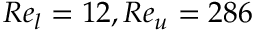<formula> <loc_0><loc_0><loc_500><loc_500>R e _ { l } = 1 2 , R e _ { u } = 2 8 6</formula> 